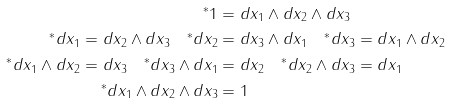<formula> <loc_0><loc_0><loc_500><loc_500>^ { * } 1 & = d x _ { 1 } \wedge d x _ { 2 } \wedge d x _ { 3 } \\ ^ { * } d x _ { 1 } = d x _ { 2 } \wedge d x _ { 3 } \quad ^ { * } d x _ { 2 } & = d x _ { 3 } \wedge d x _ { 1 } \quad ^ { * } d x _ { 3 } = d x _ { 1 } \wedge d x _ { 2 } \\ ^ { * } d x _ { 1 } \wedge d x _ { 2 } = d x _ { 3 } \quad ^ { * } d x _ { 3 } \wedge d x _ { 1 } & = d x _ { 2 } \quad ^ { * } d x _ { 2 } \wedge d x _ { 3 } = d x _ { 1 } \\ ^ { * } d x _ { 1 } \wedge d x _ { 2 } \wedge d x _ { 3 } & = 1</formula> 